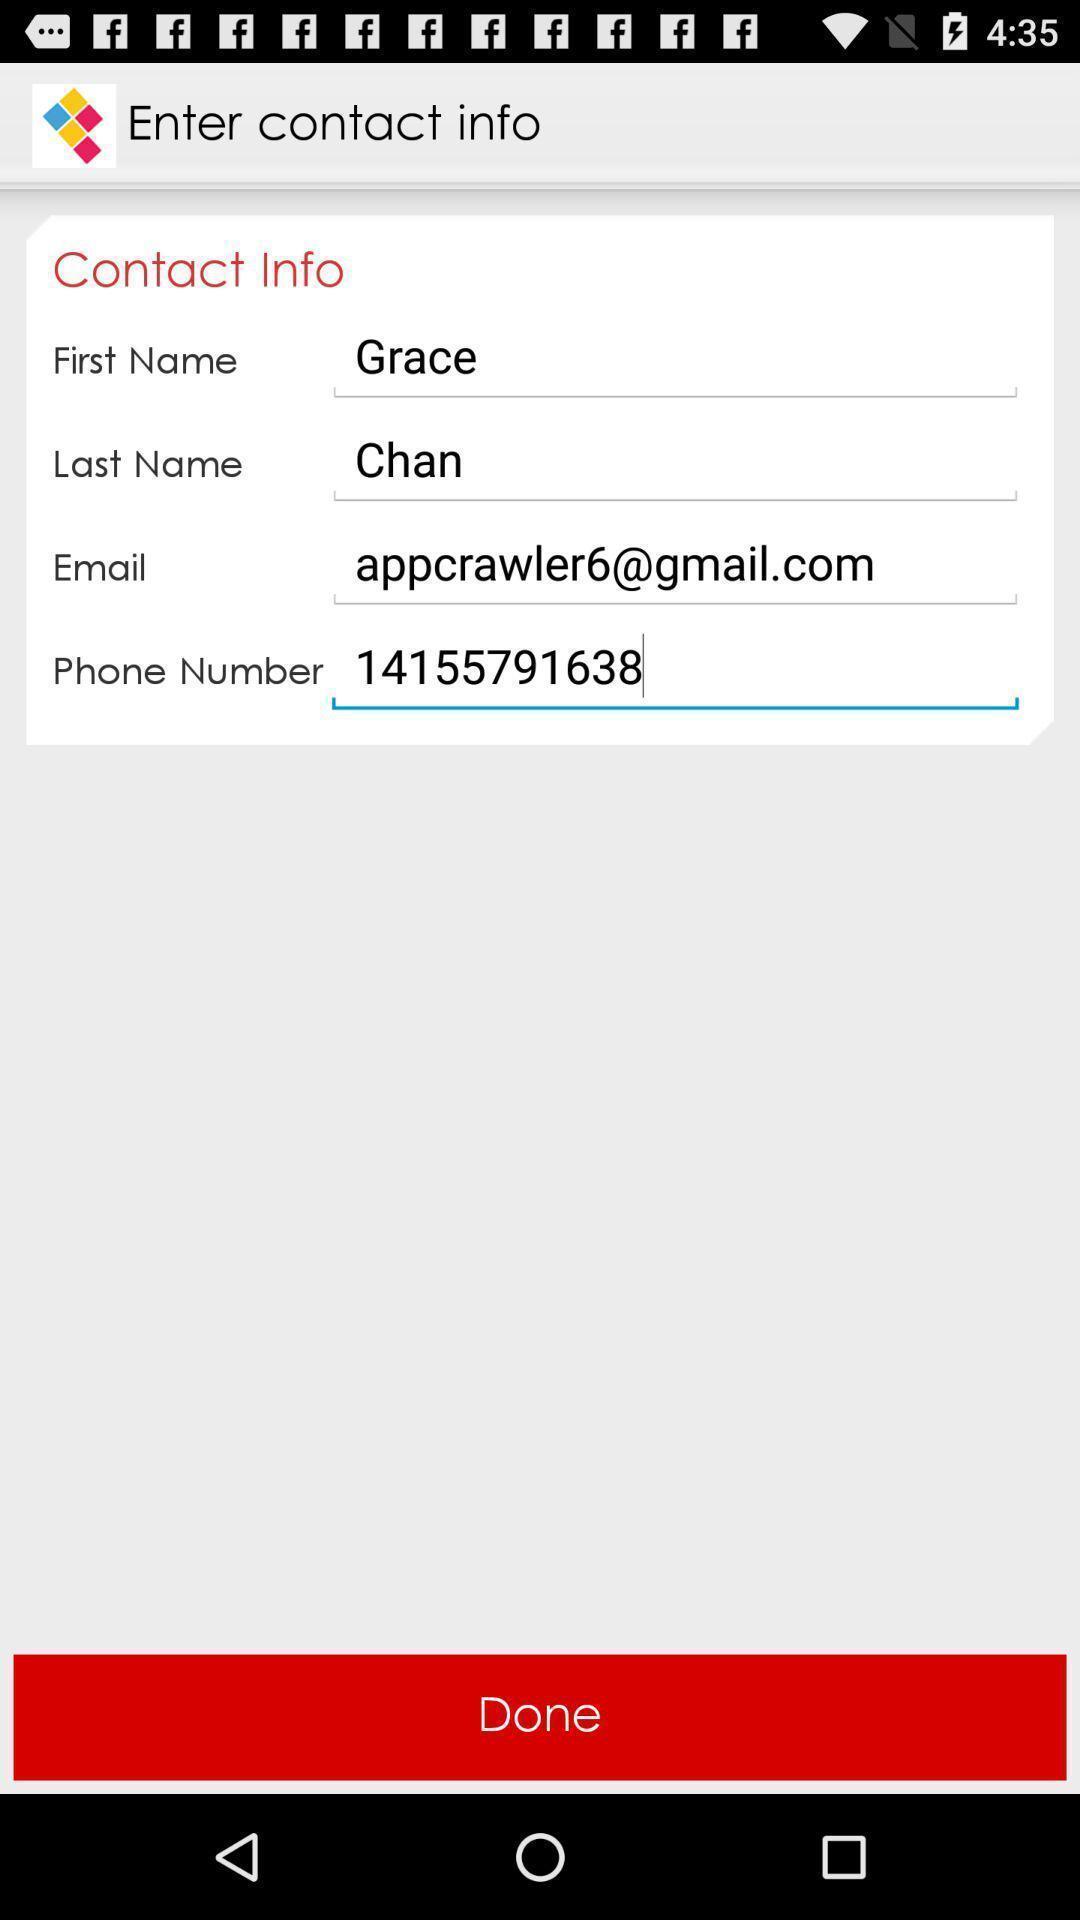Describe this image in words. Page showing contact details in a photo printing app. 